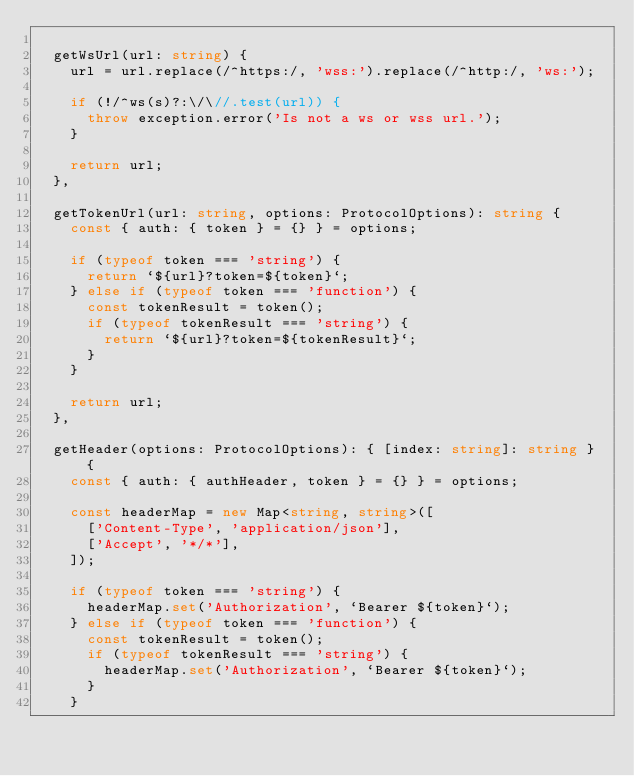Convert code to text. <code><loc_0><loc_0><loc_500><loc_500><_TypeScript_>
  getWsUrl(url: string) {
    url = url.replace(/^https:/, 'wss:').replace(/^http:/, 'ws:');

    if (!/^ws(s)?:\/\//.test(url)) {
      throw exception.error('Is not a ws or wss url.');
    }

    return url;
  },

  getTokenUrl(url: string, options: ProtocolOptions): string {
    const { auth: { token } = {} } = options;

    if (typeof token === 'string') {
      return `${url}?token=${token}`;
    } else if (typeof token === 'function') {
      const tokenResult = token();
      if (typeof tokenResult === 'string') {
        return `${url}?token=${tokenResult}`;
      }
    }

    return url;
  },

  getHeader(options: ProtocolOptions): { [index: string]: string } {
    const { auth: { authHeader, token } = {} } = options;

    const headerMap = new Map<string, string>([
      ['Content-Type', 'application/json'],
      ['Accept', '*/*'],
    ]);

    if (typeof token === 'string') {
      headerMap.set('Authorization', `Bearer ${token}`);
    } else if (typeof token === 'function') {
      const tokenResult = token();
      if (typeof tokenResult === 'string') {
        headerMap.set('Authorization', `Bearer ${token}`);
      }
    }
</code> 